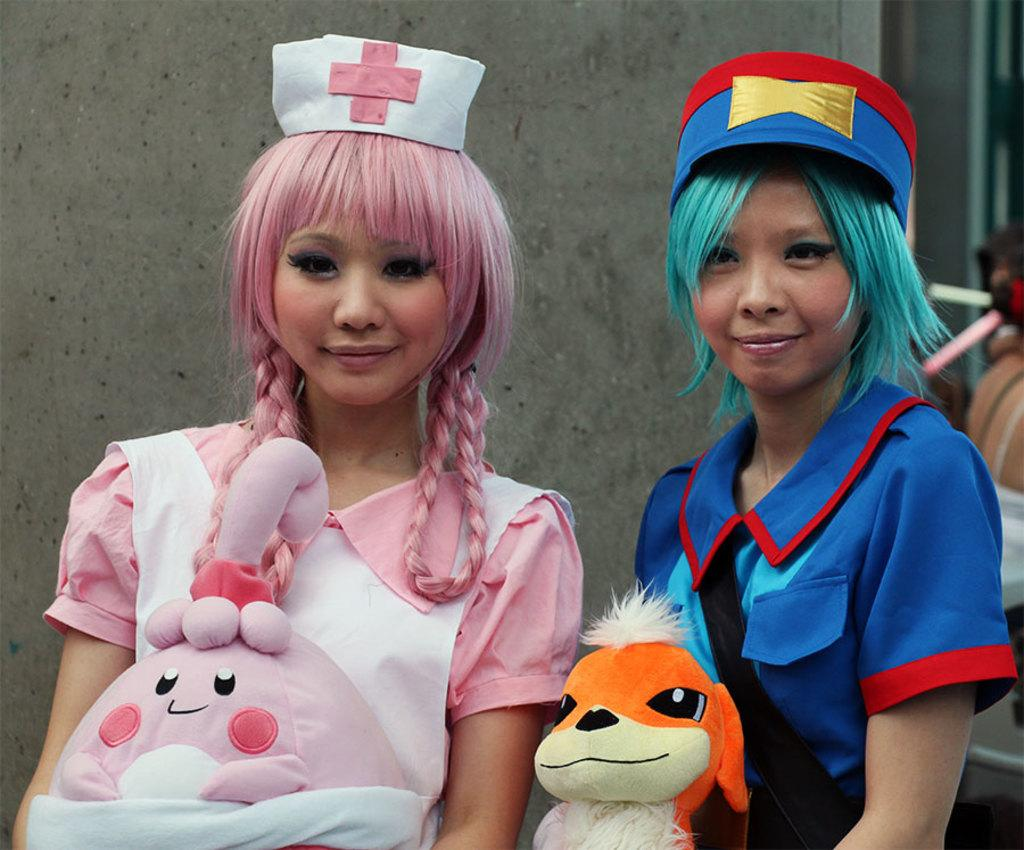Who can be seen in the foreground of the image? There are two ladies in the foreground of the image. What are the ladies wearing on their heads? The ladies are wearing caps. What are the ladies holding in their hands? The ladies are holding toys in their hands. What can be seen in the background of the image? There is a wall in the background of the image. Can you suggest a card game that the ladies might be playing in the image? There is no card game visible in the image, as the ladies are holding toys in their hands. 